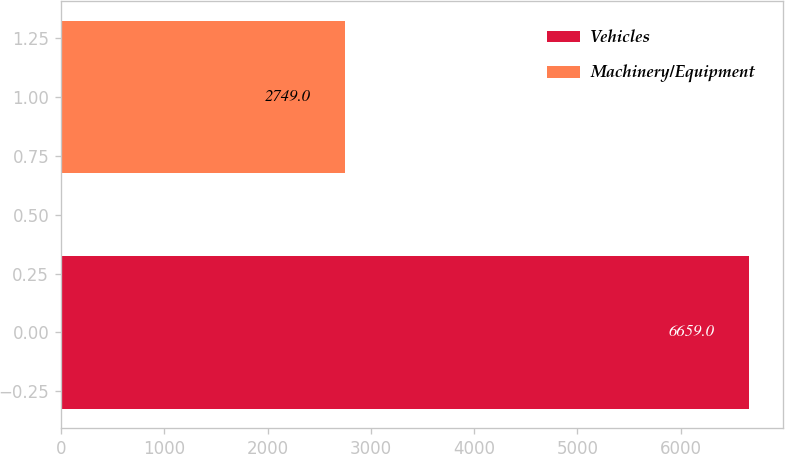Convert chart. <chart><loc_0><loc_0><loc_500><loc_500><bar_chart><fcel>Vehicles<fcel>Machinery/Equipment<nl><fcel>6659<fcel>2749<nl></chart> 